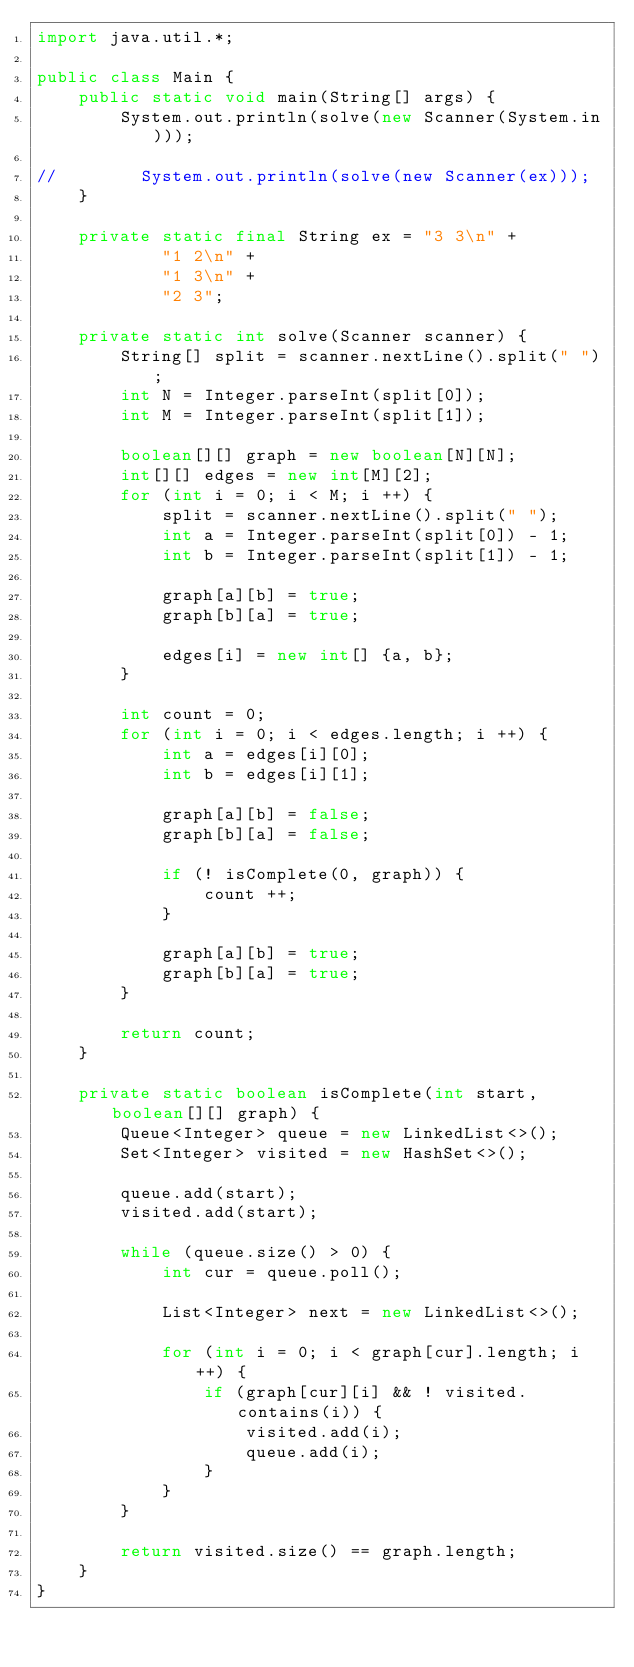Convert code to text. <code><loc_0><loc_0><loc_500><loc_500><_Java_>import java.util.*;

public class Main {
    public static void main(String[] args) {
        System.out.println(solve(new Scanner(System.in)));

//        System.out.println(solve(new Scanner(ex)));
    }

    private static final String ex = "3 3\n" +
            "1 2\n" +
            "1 3\n" +
            "2 3";

    private static int solve(Scanner scanner) {
        String[] split = scanner.nextLine().split(" ");
        int N = Integer.parseInt(split[0]);
        int M = Integer.parseInt(split[1]);

        boolean[][] graph = new boolean[N][N];
        int[][] edges = new int[M][2];
        for (int i = 0; i < M; i ++) {
            split = scanner.nextLine().split(" ");
            int a = Integer.parseInt(split[0]) - 1;
            int b = Integer.parseInt(split[1]) - 1;

            graph[a][b] = true;
            graph[b][a] = true;

            edges[i] = new int[] {a, b};
        }

        int count = 0;
        for (int i = 0; i < edges.length; i ++) {
            int a = edges[i][0];
            int b = edges[i][1];

            graph[a][b] = false;
            graph[b][a] = false;

            if (! isComplete(0, graph)) {
                count ++;
            }

            graph[a][b] = true;
            graph[b][a] = true;
        }

        return count;
    }

    private static boolean isComplete(int start, boolean[][] graph) {
        Queue<Integer> queue = new LinkedList<>();
        Set<Integer> visited = new HashSet<>();

        queue.add(start);
        visited.add(start);

        while (queue.size() > 0) {
            int cur = queue.poll();

            List<Integer> next = new LinkedList<>();

            for (int i = 0; i < graph[cur].length; i ++) {
                if (graph[cur][i] && ! visited.contains(i)) {
                    visited.add(i);
                    queue.add(i);
                }
            }
        }

        return visited.size() == graph.length;
    }
}</code> 